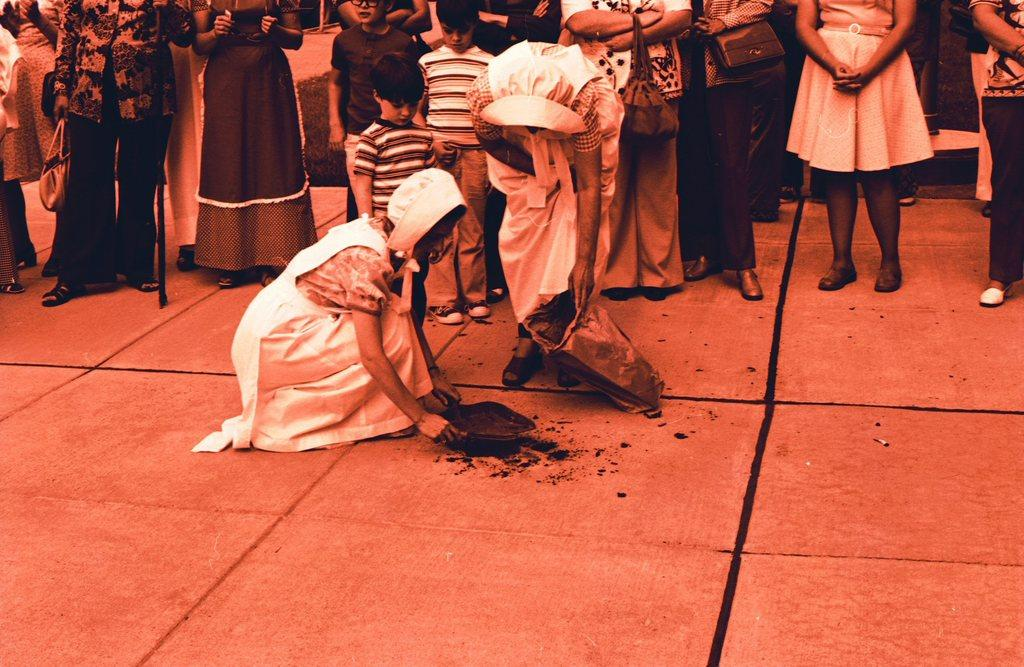How many people are in the image? There are people in the image. What are some of the positions the people are in? Some people are standing, and a woman is in a squat position. What are the women holding in their hands? Two women are holding objects in their hands. What type of lock is the man holding in the image? There is no lock present in the image. What sound does the horn make in the image? There is no horn present in the image. 